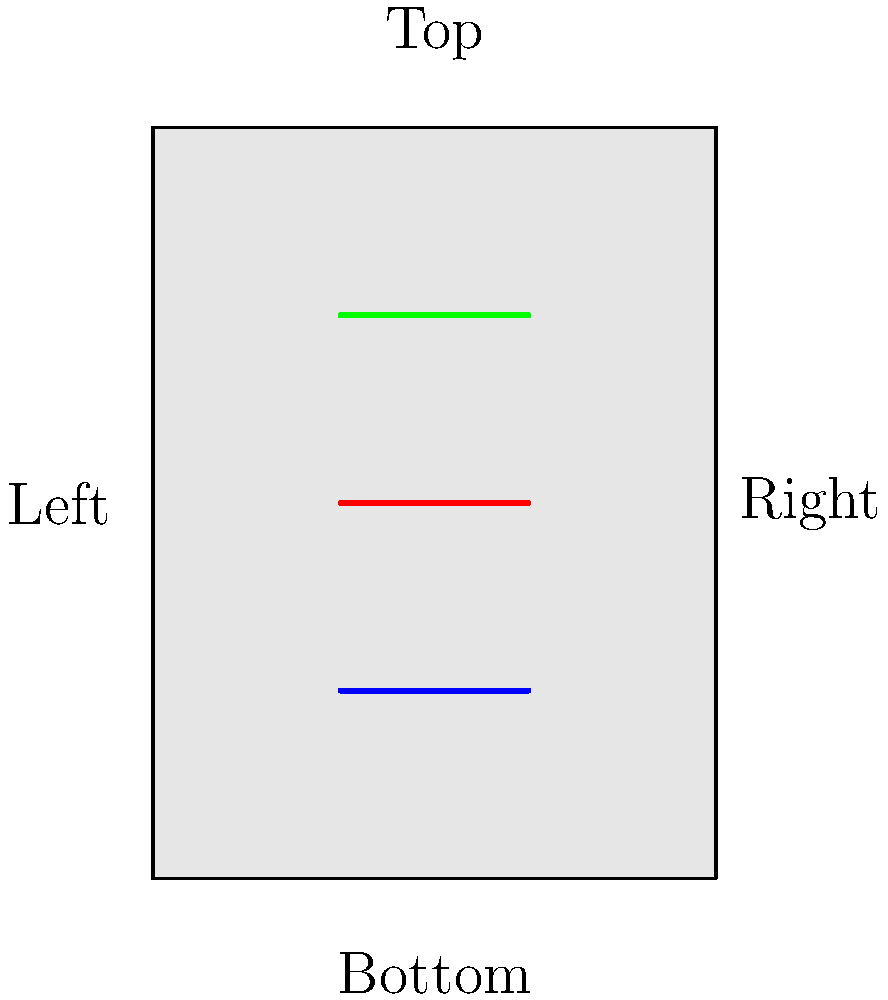A classic film noir poster has been rotated for a unique display in your cinema studies classroom. If the poster were to be correctly oriented, which direction would the current "Top" label be facing? To determine the correct orientation of the rotated movie poster, we need to follow these steps:

1. Observe the current orientation of the poster in the image.
2. Note that the poster has been rotated 45 degrees clockwise from its original position.
3. Visualize the poster rotated back 45 degrees counterclockwise to its correct orientation.
4. Identify which direction the current "Top" label would be facing after this rotation.

When we mentally rotate the poster 45 degrees counterclockwise:
- The current "Top" label would move to the upper-right corner.
- The current "Right" label would move to the top.
- The current "Bottom" label would move to the lower-left corner.
- The current "Left" label would move to the bottom.

Therefore, in the correct orientation, the current "Top" label would be facing the right side of the poster.
Answer: Right 